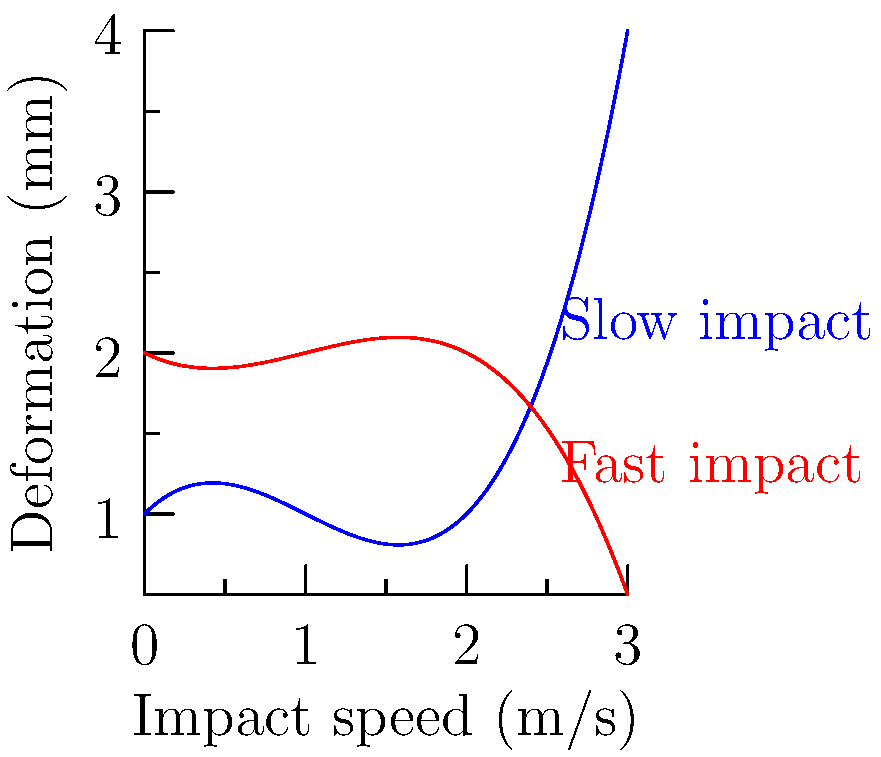The graph shows the deformation of a squash ball upon impact at various speeds for two different scenarios: slow impact and fast impact. Which of the following statements is true about the topology of these curves?

a) The slow impact curve is homeomorphic to the fast impact curve.
b) The slow impact curve has a different genus than the fast impact curve.
c) The slow impact curve and fast impact curve are not homotopy equivalent.
d) The slow impact curve and fast impact curve have different fundamental groups. Let's analyze this step-by-step:

1) First, we need to understand what these topological concepts mean:
   - Homeomorphism: A continuous bijection with a continuous inverse.
   - Genus: The number of "holes" in a surface.
   - Homotopy equivalence: A relation between two topological spaces that have the same basic shape.
   - Fundamental group: A group that captures the essence of a topological space's connectivity.

2) Looking at the curves:
   - Both curves are continuous and have no self-intersections.
   - Both curves start and end at different points.
   - Both curves are essentially smooth deformations of a line segment.

3) Analyzing the options:
   a) The curves are indeed homeomorphic. We can continuously deform one into the other without breaking or gluing.
   b) Both curves have a genus of 0 (no holes), so this statement is false.
   c) The curves are homotopy equivalent as they can be continuously deformed into each other. This statement is false.
   d) Both curves have trivial fundamental groups (they are simply connected), so this statement is false.

4) Therefore, the correct answer is option a). The slow impact curve is homeomorphic to the fast impact curve.

This relates to a squash player's understanding of how the ball deforms differently at various impact speeds, which is crucial for predicting ball behavior and adjusting playing style accordingly.
Answer: a) The slow impact curve is homeomorphic to the fast impact curve. 